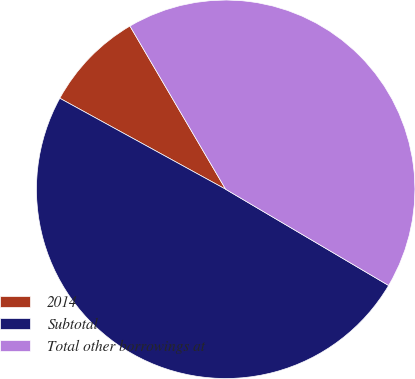Convert chart to OTSL. <chart><loc_0><loc_0><loc_500><loc_500><pie_chart><fcel>2014<fcel>Subtotal<fcel>Total other borrowings at<nl><fcel>8.57%<fcel>49.5%<fcel>41.93%<nl></chart> 